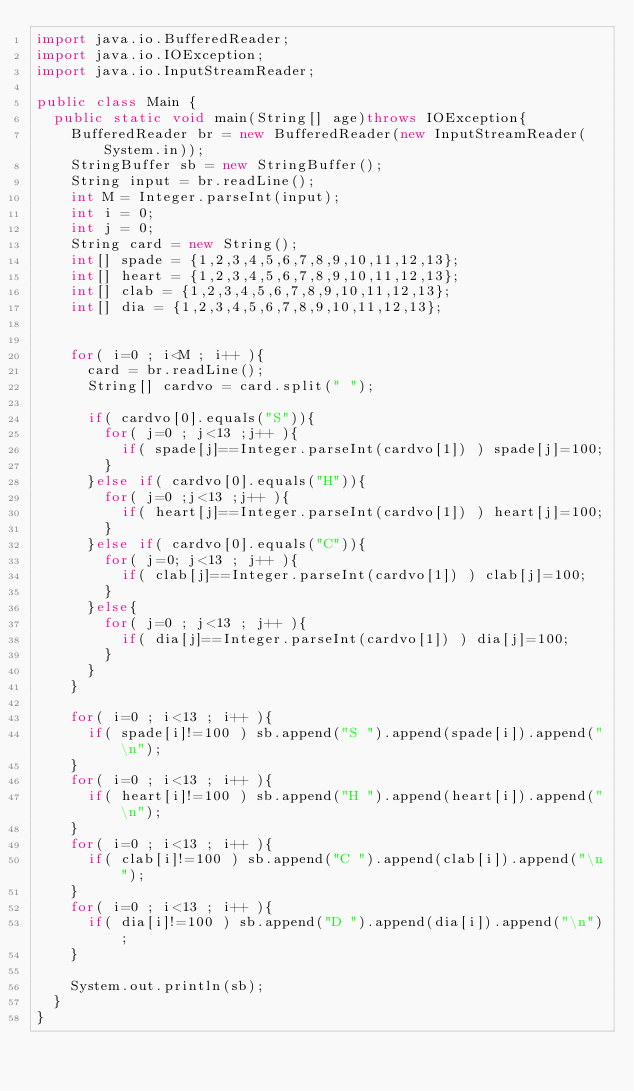<code> <loc_0><loc_0><loc_500><loc_500><_Java_>import java.io.BufferedReader;
import java.io.IOException;
import java.io.InputStreamReader;

public class Main {
	public static void main(String[] age)throws IOException{
		BufferedReader br = new BufferedReader(new InputStreamReader(System.in));
		StringBuffer sb = new StringBuffer();
		String input = br.readLine();
		int M = Integer.parseInt(input);
		int i = 0;
		int j = 0;
		String card = new String();
		int[] spade = {1,2,3,4,5,6,7,8,9,10,11,12,13};
		int[] heart = {1,2,3,4,5,6,7,8,9,10,11,12,13};
		int[] clab = {1,2,3,4,5,6,7,8,9,10,11,12,13};
		int[] dia = {1,2,3,4,5,6,7,8,9,10,11,12,13};


		for( i=0 ; i<M ; i++ ){
			card = br.readLine();
			String[] cardvo = card.split(" ");

			if( cardvo[0].equals("S")){
				for( j=0 ; j<13 ;j++ ){
					if( spade[j]==Integer.parseInt(cardvo[1]) ) spade[j]=100;
				}
			}else if( cardvo[0].equals("H")){
				for( j=0 ;j<13 ;j++ ){
					if( heart[j]==Integer.parseInt(cardvo[1]) ) heart[j]=100;
				}
			}else if( cardvo[0].equals("C")){
				for( j=0; j<13 ; j++ ){
					if( clab[j]==Integer.parseInt(cardvo[1]) ) clab[j]=100;
				}
			}else{
				for( j=0 ; j<13 ; j++ ){
					if( dia[j]==Integer.parseInt(cardvo[1]) ) dia[j]=100;
				}
			}
		}

		for( i=0 ; i<13 ; i++ ){
			if( spade[i]!=100 ) sb.append("S ").append(spade[i]).append("\n");
		}
		for( i=0 ; i<13 ; i++ ){
			if( heart[i]!=100 ) sb.append("H ").append(heart[i]).append("\n");
		}
		for( i=0 ; i<13 ; i++ ){
			if( clab[i]!=100 ) sb.append("C ").append(clab[i]).append("\n");
		}
		for( i=0 ; i<13 ; i++ ){
			if( dia[i]!=100 ) sb.append("D ").append(dia[i]).append("\n");
		}

		System.out.println(sb);
	}
}</code> 